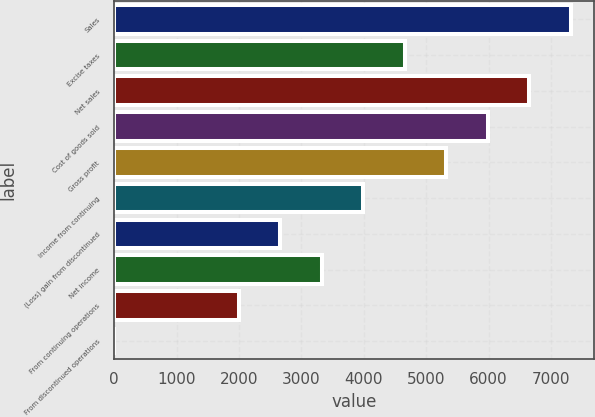Convert chart. <chart><loc_0><loc_0><loc_500><loc_500><bar_chart><fcel>Sales<fcel>Excise taxes<fcel>Net sales<fcel>Cost of goods sold<fcel>Gross profit<fcel>Income from continuing<fcel>(Loss) gain from discontinued<fcel>Net income<fcel>From continuing operations<fcel>From discontinued operations<nl><fcel>7316.94<fcel>4656.26<fcel>6651.77<fcel>5986.6<fcel>5321.43<fcel>3991.09<fcel>2660.75<fcel>3325.92<fcel>1995.58<fcel>0.07<nl></chart> 